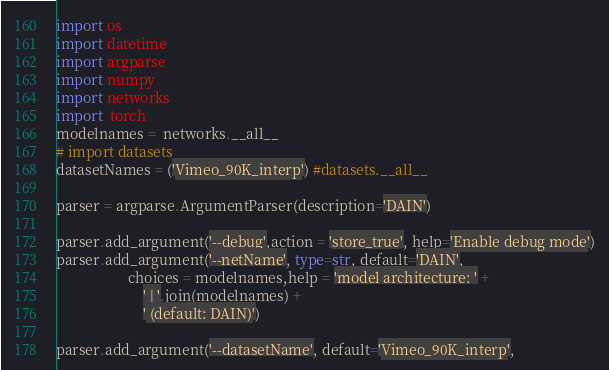<code> <loc_0><loc_0><loc_500><loc_500><_Python_>import os
import datetime
import argparse
import numpy
import networks
import  torch
modelnames =  networks.__all__
# import datasets
datasetNames = ('Vimeo_90K_interp') #datasets.__all__

parser = argparse.ArgumentParser(description='DAIN')

parser.add_argument('--debug',action = 'store_true', help='Enable debug mode')
parser.add_argument('--netName', type=str, default='DAIN',
                    choices = modelnames,help = 'model architecture: ' +
                        ' | '.join(modelnames) +
                        ' (default: DAIN)')

parser.add_argument('--datasetName', default='Vimeo_90K_interp',</code> 